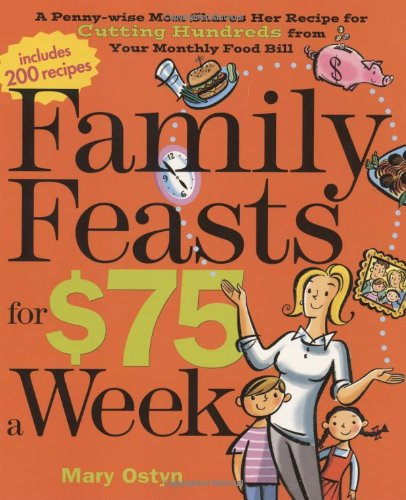How does the author suggest planning meals to stay under the $75 weekly budget? The author suggests planning meals around sales and seasonal produce, using a flexible meal planning strategy, and incorporating leftovers creatively to maximize the food budget. 